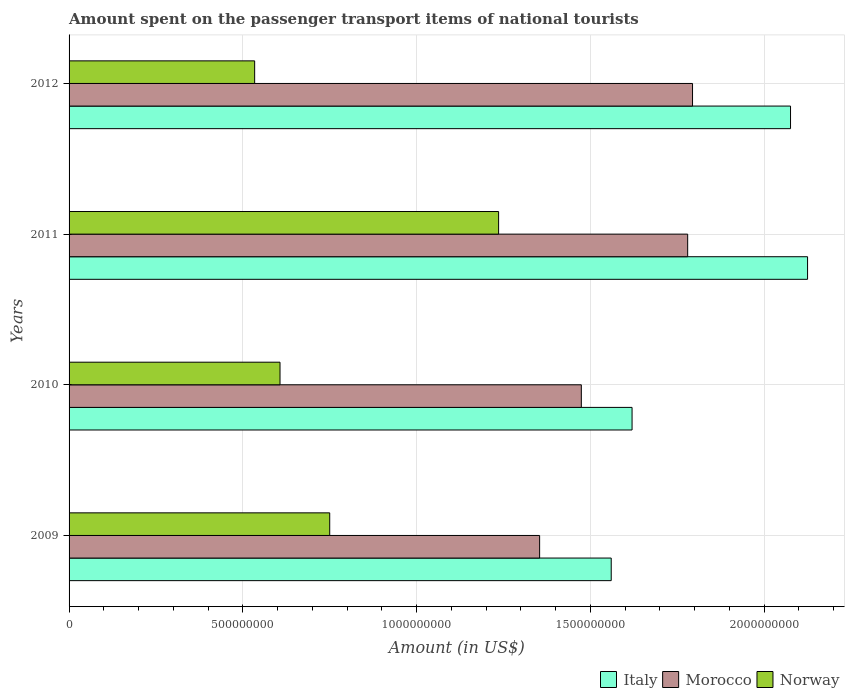How many different coloured bars are there?
Your response must be concise. 3. Are the number of bars per tick equal to the number of legend labels?
Provide a succinct answer. Yes. Are the number of bars on each tick of the Y-axis equal?
Offer a terse response. Yes. What is the amount spent on the passenger transport items of national tourists in Norway in 2012?
Ensure brevity in your answer.  5.34e+08. Across all years, what is the maximum amount spent on the passenger transport items of national tourists in Italy?
Your answer should be very brief. 2.12e+09. Across all years, what is the minimum amount spent on the passenger transport items of national tourists in Norway?
Offer a terse response. 5.34e+08. In which year was the amount spent on the passenger transport items of national tourists in Norway maximum?
Offer a very short reply. 2011. What is the total amount spent on the passenger transport items of national tourists in Italy in the graph?
Keep it short and to the point. 7.38e+09. What is the difference between the amount spent on the passenger transport items of national tourists in Norway in 2010 and that in 2012?
Provide a succinct answer. 7.30e+07. What is the difference between the amount spent on the passenger transport items of national tourists in Italy in 2010 and the amount spent on the passenger transport items of national tourists in Morocco in 2012?
Keep it short and to the point. -1.74e+08. What is the average amount spent on the passenger transport items of national tourists in Norway per year?
Provide a succinct answer. 7.82e+08. In the year 2010, what is the difference between the amount spent on the passenger transport items of national tourists in Italy and amount spent on the passenger transport items of national tourists in Norway?
Your response must be concise. 1.01e+09. In how many years, is the amount spent on the passenger transport items of national tourists in Italy greater than 2100000000 US$?
Ensure brevity in your answer.  1. What is the ratio of the amount spent on the passenger transport items of national tourists in Norway in 2009 to that in 2011?
Your answer should be compact. 0.61. What is the difference between the highest and the second highest amount spent on the passenger transport items of national tourists in Morocco?
Provide a succinct answer. 1.40e+07. What is the difference between the highest and the lowest amount spent on the passenger transport items of national tourists in Norway?
Your response must be concise. 7.02e+08. Is the sum of the amount spent on the passenger transport items of national tourists in Norway in 2009 and 2011 greater than the maximum amount spent on the passenger transport items of national tourists in Italy across all years?
Offer a terse response. No. What does the 1st bar from the bottom in 2009 represents?
Offer a terse response. Italy. How many years are there in the graph?
Make the answer very short. 4. What is the difference between two consecutive major ticks on the X-axis?
Offer a terse response. 5.00e+08. Are the values on the major ticks of X-axis written in scientific E-notation?
Provide a short and direct response. No. Does the graph contain any zero values?
Your answer should be very brief. No. How many legend labels are there?
Your answer should be compact. 3. What is the title of the graph?
Offer a terse response. Amount spent on the passenger transport items of national tourists. Does "Jamaica" appear as one of the legend labels in the graph?
Give a very brief answer. No. What is the Amount (in US$) in Italy in 2009?
Your answer should be very brief. 1.56e+09. What is the Amount (in US$) in Morocco in 2009?
Keep it short and to the point. 1.35e+09. What is the Amount (in US$) in Norway in 2009?
Offer a terse response. 7.50e+08. What is the Amount (in US$) of Italy in 2010?
Provide a succinct answer. 1.62e+09. What is the Amount (in US$) in Morocco in 2010?
Keep it short and to the point. 1.47e+09. What is the Amount (in US$) of Norway in 2010?
Offer a very short reply. 6.07e+08. What is the Amount (in US$) in Italy in 2011?
Keep it short and to the point. 2.12e+09. What is the Amount (in US$) in Morocco in 2011?
Ensure brevity in your answer.  1.78e+09. What is the Amount (in US$) in Norway in 2011?
Offer a very short reply. 1.24e+09. What is the Amount (in US$) of Italy in 2012?
Your response must be concise. 2.08e+09. What is the Amount (in US$) of Morocco in 2012?
Keep it short and to the point. 1.79e+09. What is the Amount (in US$) in Norway in 2012?
Give a very brief answer. 5.34e+08. Across all years, what is the maximum Amount (in US$) of Italy?
Offer a very short reply. 2.12e+09. Across all years, what is the maximum Amount (in US$) in Morocco?
Your answer should be compact. 1.79e+09. Across all years, what is the maximum Amount (in US$) in Norway?
Keep it short and to the point. 1.24e+09. Across all years, what is the minimum Amount (in US$) in Italy?
Provide a short and direct response. 1.56e+09. Across all years, what is the minimum Amount (in US$) of Morocco?
Offer a very short reply. 1.35e+09. Across all years, what is the minimum Amount (in US$) of Norway?
Keep it short and to the point. 5.34e+08. What is the total Amount (in US$) in Italy in the graph?
Offer a terse response. 7.38e+09. What is the total Amount (in US$) in Morocco in the graph?
Ensure brevity in your answer.  6.40e+09. What is the total Amount (in US$) of Norway in the graph?
Your response must be concise. 3.13e+09. What is the difference between the Amount (in US$) of Italy in 2009 and that in 2010?
Make the answer very short. -6.00e+07. What is the difference between the Amount (in US$) in Morocco in 2009 and that in 2010?
Your answer should be compact. -1.20e+08. What is the difference between the Amount (in US$) in Norway in 2009 and that in 2010?
Your answer should be compact. 1.43e+08. What is the difference between the Amount (in US$) in Italy in 2009 and that in 2011?
Give a very brief answer. -5.65e+08. What is the difference between the Amount (in US$) of Morocco in 2009 and that in 2011?
Make the answer very short. -4.26e+08. What is the difference between the Amount (in US$) in Norway in 2009 and that in 2011?
Provide a succinct answer. -4.86e+08. What is the difference between the Amount (in US$) in Italy in 2009 and that in 2012?
Provide a short and direct response. -5.16e+08. What is the difference between the Amount (in US$) of Morocco in 2009 and that in 2012?
Provide a short and direct response. -4.40e+08. What is the difference between the Amount (in US$) in Norway in 2009 and that in 2012?
Provide a succinct answer. 2.16e+08. What is the difference between the Amount (in US$) in Italy in 2010 and that in 2011?
Make the answer very short. -5.05e+08. What is the difference between the Amount (in US$) in Morocco in 2010 and that in 2011?
Keep it short and to the point. -3.06e+08. What is the difference between the Amount (in US$) of Norway in 2010 and that in 2011?
Offer a very short reply. -6.29e+08. What is the difference between the Amount (in US$) in Italy in 2010 and that in 2012?
Your response must be concise. -4.56e+08. What is the difference between the Amount (in US$) in Morocco in 2010 and that in 2012?
Give a very brief answer. -3.20e+08. What is the difference between the Amount (in US$) in Norway in 2010 and that in 2012?
Your answer should be very brief. 7.30e+07. What is the difference between the Amount (in US$) of Italy in 2011 and that in 2012?
Ensure brevity in your answer.  4.90e+07. What is the difference between the Amount (in US$) in Morocco in 2011 and that in 2012?
Provide a succinct answer. -1.40e+07. What is the difference between the Amount (in US$) in Norway in 2011 and that in 2012?
Make the answer very short. 7.02e+08. What is the difference between the Amount (in US$) in Italy in 2009 and the Amount (in US$) in Morocco in 2010?
Provide a short and direct response. 8.60e+07. What is the difference between the Amount (in US$) in Italy in 2009 and the Amount (in US$) in Norway in 2010?
Give a very brief answer. 9.53e+08. What is the difference between the Amount (in US$) in Morocco in 2009 and the Amount (in US$) in Norway in 2010?
Provide a short and direct response. 7.47e+08. What is the difference between the Amount (in US$) in Italy in 2009 and the Amount (in US$) in Morocco in 2011?
Give a very brief answer. -2.20e+08. What is the difference between the Amount (in US$) of Italy in 2009 and the Amount (in US$) of Norway in 2011?
Provide a short and direct response. 3.24e+08. What is the difference between the Amount (in US$) in Morocco in 2009 and the Amount (in US$) in Norway in 2011?
Keep it short and to the point. 1.18e+08. What is the difference between the Amount (in US$) in Italy in 2009 and the Amount (in US$) in Morocco in 2012?
Ensure brevity in your answer.  -2.34e+08. What is the difference between the Amount (in US$) in Italy in 2009 and the Amount (in US$) in Norway in 2012?
Give a very brief answer. 1.03e+09. What is the difference between the Amount (in US$) of Morocco in 2009 and the Amount (in US$) of Norway in 2012?
Provide a succinct answer. 8.20e+08. What is the difference between the Amount (in US$) of Italy in 2010 and the Amount (in US$) of Morocco in 2011?
Give a very brief answer. -1.60e+08. What is the difference between the Amount (in US$) of Italy in 2010 and the Amount (in US$) of Norway in 2011?
Give a very brief answer. 3.84e+08. What is the difference between the Amount (in US$) of Morocco in 2010 and the Amount (in US$) of Norway in 2011?
Offer a very short reply. 2.38e+08. What is the difference between the Amount (in US$) of Italy in 2010 and the Amount (in US$) of Morocco in 2012?
Provide a succinct answer. -1.74e+08. What is the difference between the Amount (in US$) in Italy in 2010 and the Amount (in US$) in Norway in 2012?
Offer a terse response. 1.09e+09. What is the difference between the Amount (in US$) of Morocco in 2010 and the Amount (in US$) of Norway in 2012?
Provide a succinct answer. 9.40e+08. What is the difference between the Amount (in US$) of Italy in 2011 and the Amount (in US$) of Morocco in 2012?
Your response must be concise. 3.31e+08. What is the difference between the Amount (in US$) of Italy in 2011 and the Amount (in US$) of Norway in 2012?
Ensure brevity in your answer.  1.59e+09. What is the difference between the Amount (in US$) in Morocco in 2011 and the Amount (in US$) in Norway in 2012?
Make the answer very short. 1.25e+09. What is the average Amount (in US$) of Italy per year?
Offer a very short reply. 1.85e+09. What is the average Amount (in US$) of Morocco per year?
Your response must be concise. 1.60e+09. What is the average Amount (in US$) in Norway per year?
Offer a very short reply. 7.82e+08. In the year 2009, what is the difference between the Amount (in US$) in Italy and Amount (in US$) in Morocco?
Your response must be concise. 2.06e+08. In the year 2009, what is the difference between the Amount (in US$) of Italy and Amount (in US$) of Norway?
Ensure brevity in your answer.  8.10e+08. In the year 2009, what is the difference between the Amount (in US$) in Morocco and Amount (in US$) in Norway?
Ensure brevity in your answer.  6.04e+08. In the year 2010, what is the difference between the Amount (in US$) in Italy and Amount (in US$) in Morocco?
Your answer should be compact. 1.46e+08. In the year 2010, what is the difference between the Amount (in US$) in Italy and Amount (in US$) in Norway?
Your response must be concise. 1.01e+09. In the year 2010, what is the difference between the Amount (in US$) of Morocco and Amount (in US$) of Norway?
Keep it short and to the point. 8.67e+08. In the year 2011, what is the difference between the Amount (in US$) in Italy and Amount (in US$) in Morocco?
Offer a terse response. 3.45e+08. In the year 2011, what is the difference between the Amount (in US$) of Italy and Amount (in US$) of Norway?
Your answer should be compact. 8.89e+08. In the year 2011, what is the difference between the Amount (in US$) of Morocco and Amount (in US$) of Norway?
Provide a short and direct response. 5.44e+08. In the year 2012, what is the difference between the Amount (in US$) of Italy and Amount (in US$) of Morocco?
Keep it short and to the point. 2.82e+08. In the year 2012, what is the difference between the Amount (in US$) of Italy and Amount (in US$) of Norway?
Make the answer very short. 1.54e+09. In the year 2012, what is the difference between the Amount (in US$) of Morocco and Amount (in US$) of Norway?
Provide a succinct answer. 1.26e+09. What is the ratio of the Amount (in US$) of Morocco in 2009 to that in 2010?
Provide a short and direct response. 0.92. What is the ratio of the Amount (in US$) of Norway in 2009 to that in 2010?
Your answer should be very brief. 1.24. What is the ratio of the Amount (in US$) in Italy in 2009 to that in 2011?
Your answer should be compact. 0.73. What is the ratio of the Amount (in US$) in Morocco in 2009 to that in 2011?
Offer a very short reply. 0.76. What is the ratio of the Amount (in US$) of Norway in 2009 to that in 2011?
Provide a short and direct response. 0.61. What is the ratio of the Amount (in US$) in Italy in 2009 to that in 2012?
Provide a succinct answer. 0.75. What is the ratio of the Amount (in US$) in Morocco in 2009 to that in 2012?
Offer a terse response. 0.75. What is the ratio of the Amount (in US$) in Norway in 2009 to that in 2012?
Your answer should be very brief. 1.4. What is the ratio of the Amount (in US$) of Italy in 2010 to that in 2011?
Give a very brief answer. 0.76. What is the ratio of the Amount (in US$) in Morocco in 2010 to that in 2011?
Offer a very short reply. 0.83. What is the ratio of the Amount (in US$) of Norway in 2010 to that in 2011?
Make the answer very short. 0.49. What is the ratio of the Amount (in US$) of Italy in 2010 to that in 2012?
Keep it short and to the point. 0.78. What is the ratio of the Amount (in US$) in Morocco in 2010 to that in 2012?
Keep it short and to the point. 0.82. What is the ratio of the Amount (in US$) of Norway in 2010 to that in 2012?
Provide a succinct answer. 1.14. What is the ratio of the Amount (in US$) in Italy in 2011 to that in 2012?
Provide a short and direct response. 1.02. What is the ratio of the Amount (in US$) of Norway in 2011 to that in 2012?
Give a very brief answer. 2.31. What is the difference between the highest and the second highest Amount (in US$) in Italy?
Your answer should be very brief. 4.90e+07. What is the difference between the highest and the second highest Amount (in US$) in Morocco?
Provide a short and direct response. 1.40e+07. What is the difference between the highest and the second highest Amount (in US$) of Norway?
Give a very brief answer. 4.86e+08. What is the difference between the highest and the lowest Amount (in US$) in Italy?
Your answer should be compact. 5.65e+08. What is the difference between the highest and the lowest Amount (in US$) in Morocco?
Your answer should be very brief. 4.40e+08. What is the difference between the highest and the lowest Amount (in US$) of Norway?
Your answer should be very brief. 7.02e+08. 